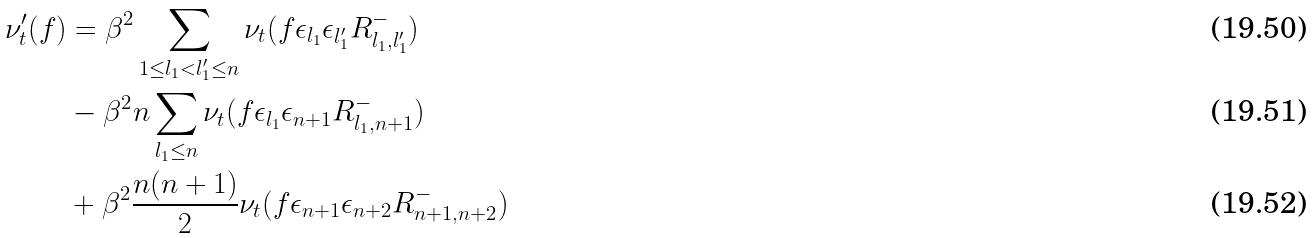Convert formula to latex. <formula><loc_0><loc_0><loc_500><loc_500>\nu _ { t } ^ { \prime } ( f ) & = \beta ^ { 2 } \sum _ { 1 \leq l _ { 1 } < l _ { 1 } ^ { \prime } \leq n } \nu _ { t } ( f \epsilon _ { l _ { 1 } } \epsilon _ { l _ { 1 } ^ { \prime } } R ^ { - } _ { l _ { 1 } , l _ { 1 } ^ { \prime } } ) \\ & - \beta ^ { 2 } n \sum _ { l _ { 1 } \leq n } \nu _ { t } ( f \epsilon _ { l _ { 1 } } \epsilon _ { n + 1 } R _ { l _ { 1 } , n + 1 } ^ { - } ) \\ & + \beta ^ { 2 } \frac { n ( n + 1 ) } { 2 } \nu _ { t } ( f \epsilon _ { n + 1 } \epsilon _ { n + 2 } R _ { n + 1 , n + 2 } ^ { - } )</formula> 